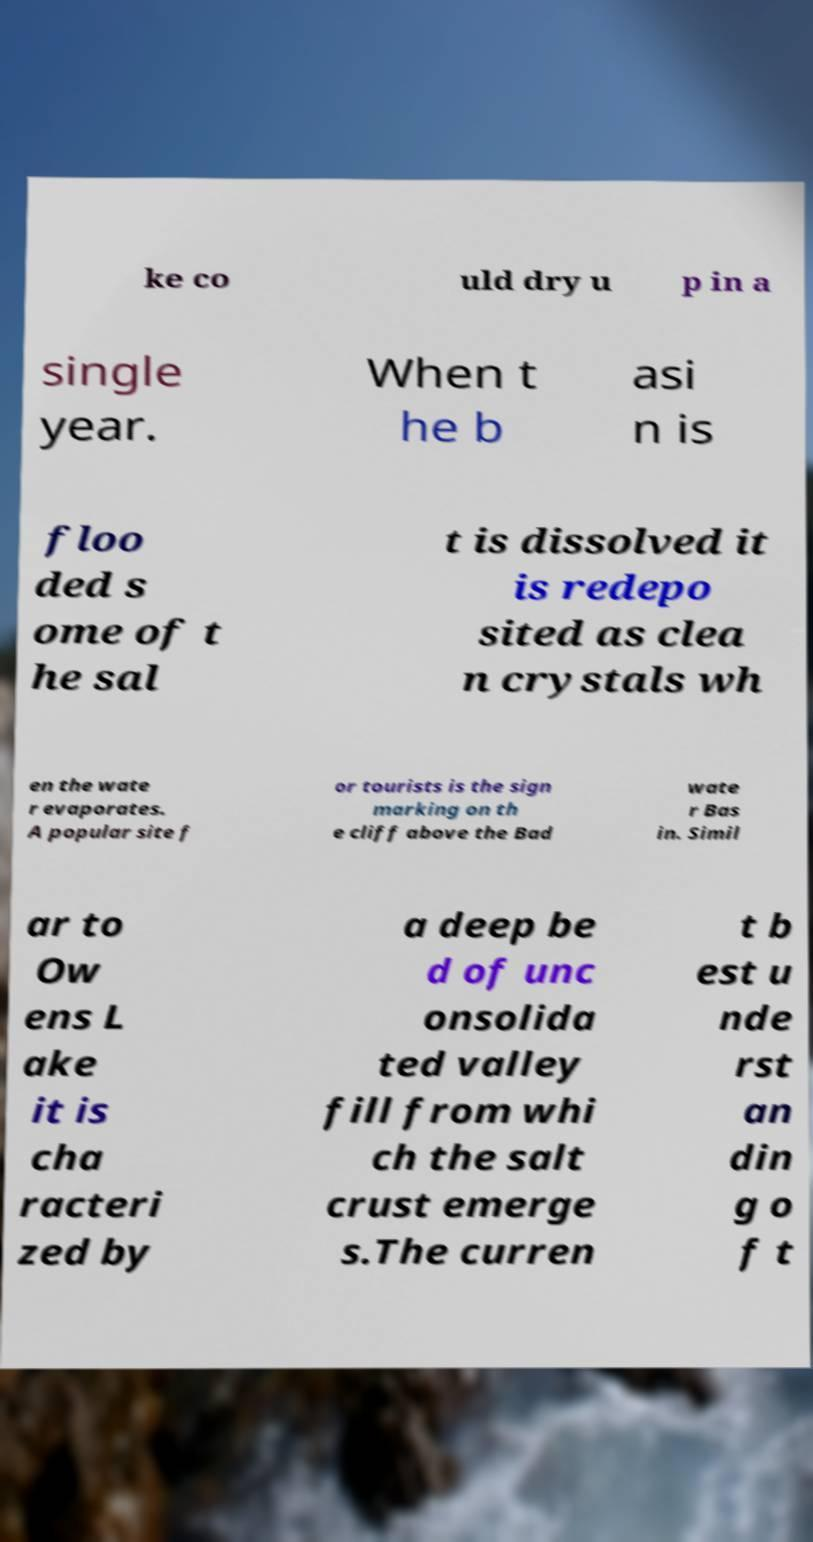I need the written content from this picture converted into text. Can you do that? ke co uld dry u p in a single year. When t he b asi n is floo ded s ome of t he sal t is dissolved it is redepo sited as clea n crystals wh en the wate r evaporates. A popular site f or tourists is the sign marking on th e cliff above the Bad wate r Bas in. Simil ar to Ow ens L ake it is cha racteri zed by a deep be d of unc onsolida ted valley fill from whi ch the salt crust emerge s.The curren t b est u nde rst an din g o f t 